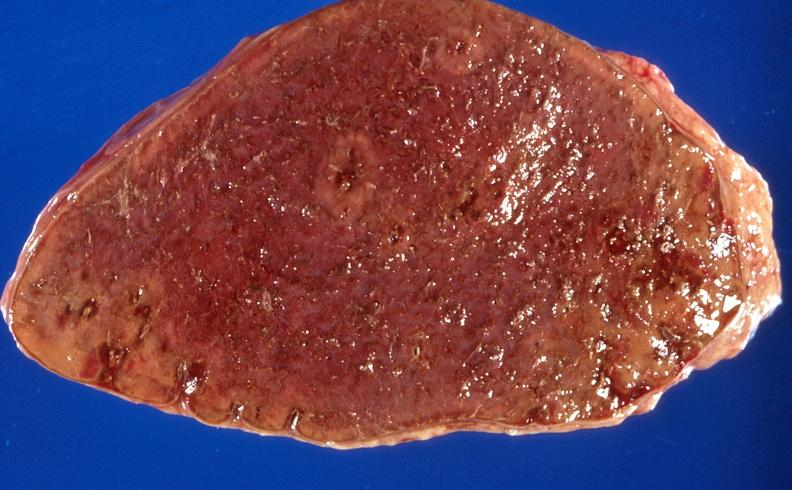does view of head with scalp show sickle cell disease, spleen?
Answer the question using a single word or phrase. No 